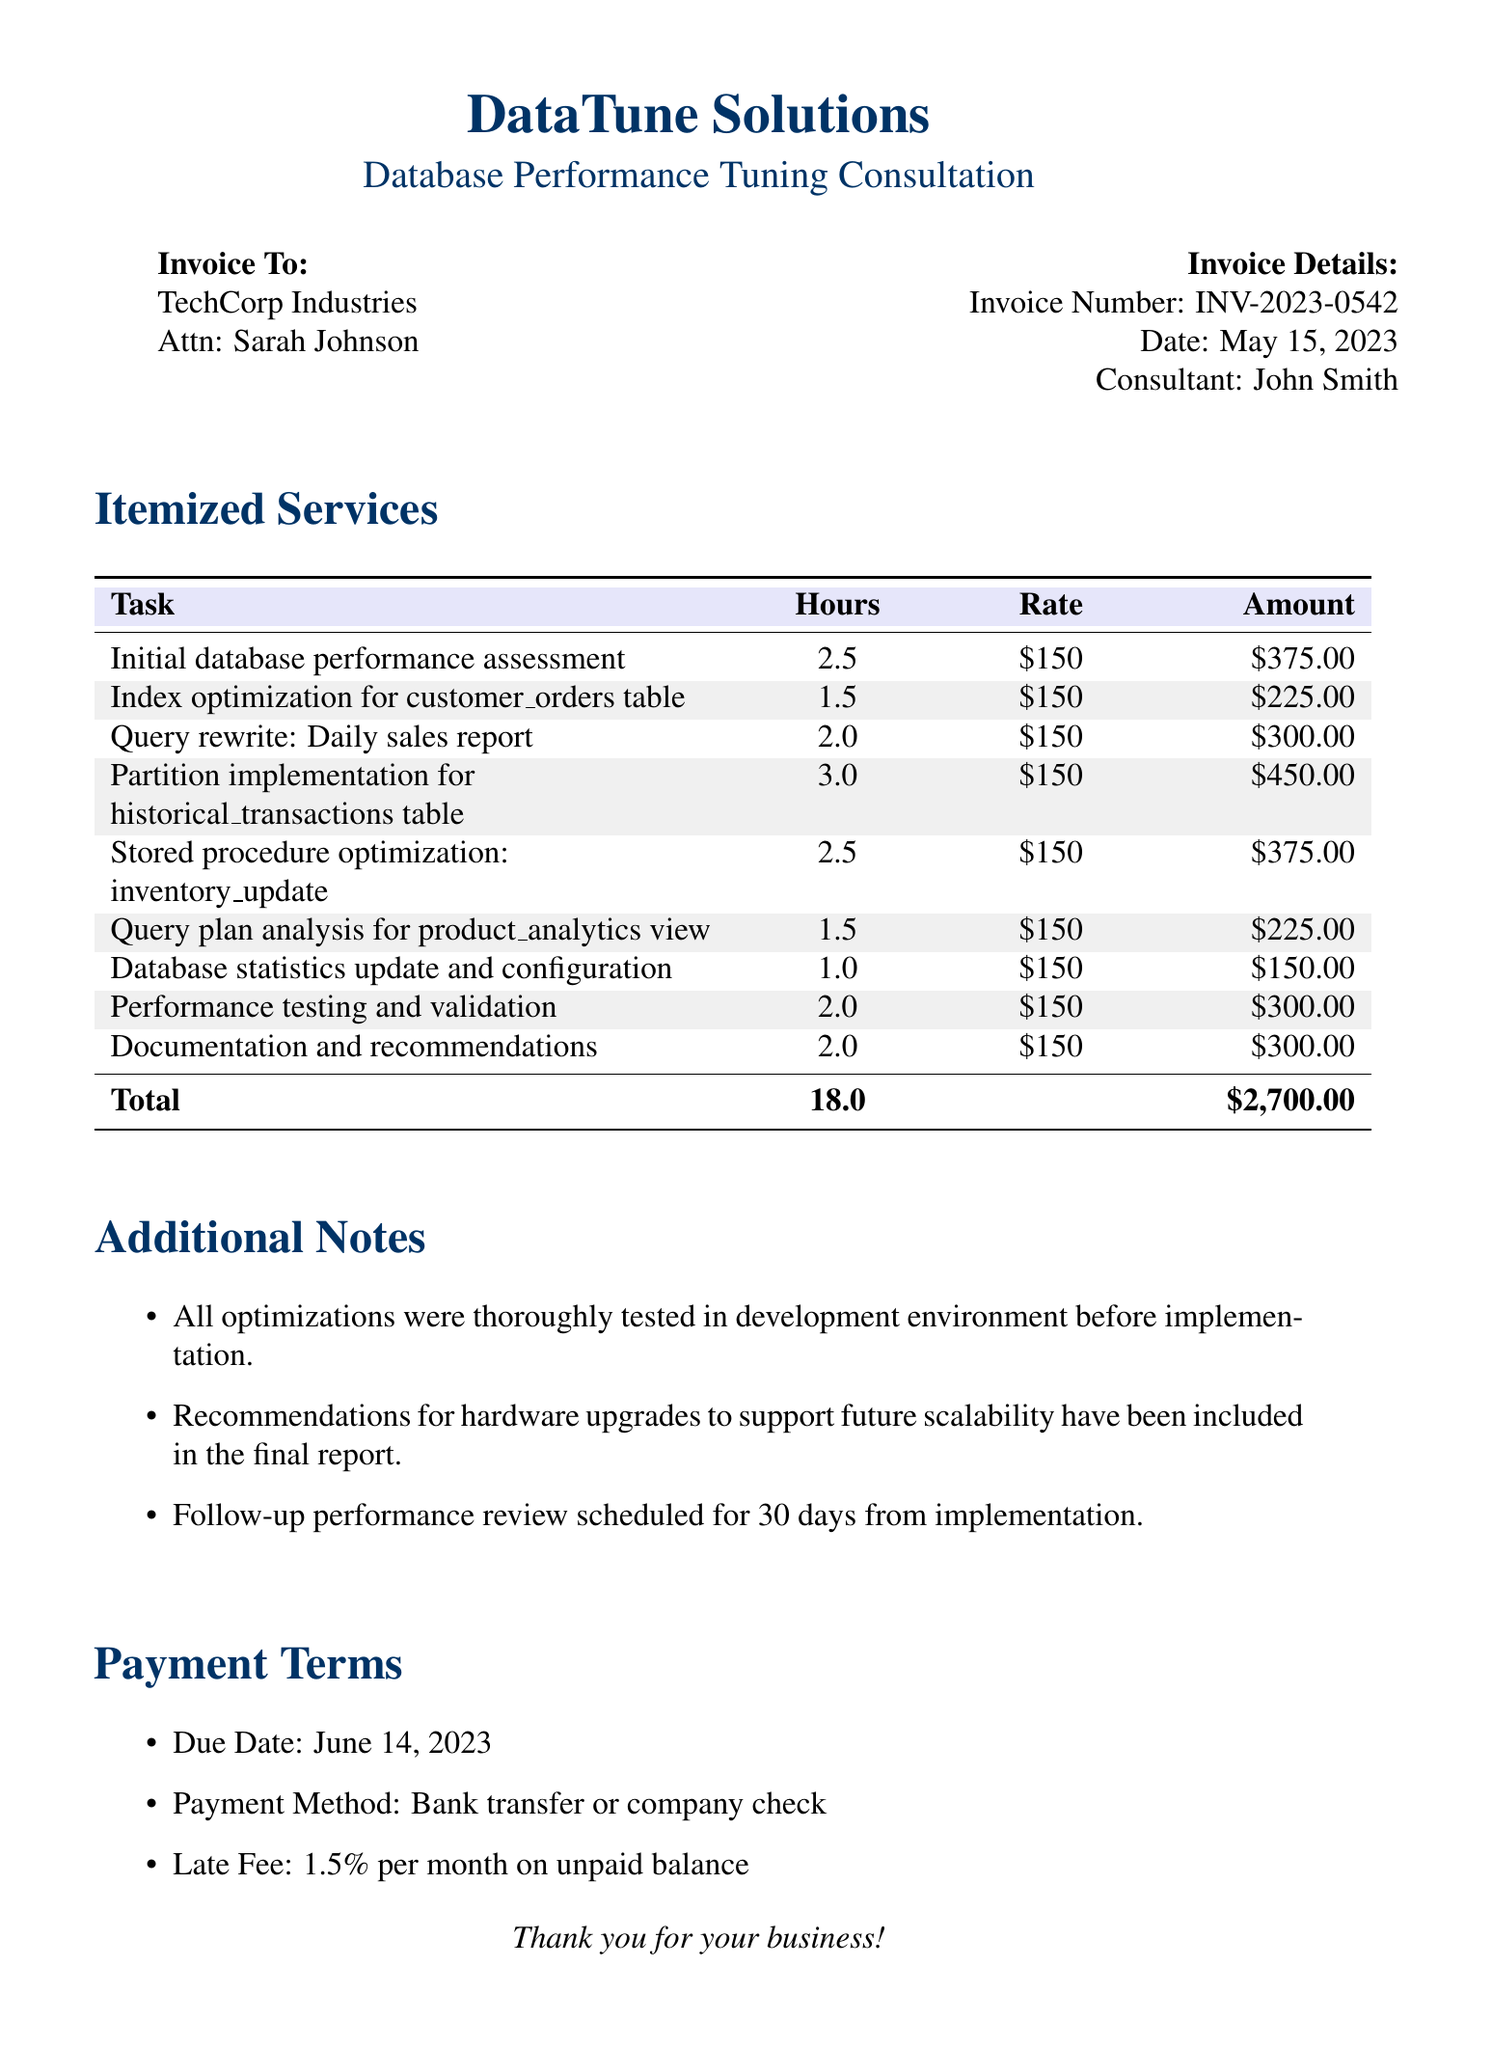what is the consultant's name? The consultant's name listed in the invoice details is John Smith.
Answer: John Smith what is the total time spent on optimization tasks? The total time spent is the sum of time spent on all listed tasks, which is 2.5 + 1.5 + 2 + 3 + 2.5 + 1.5 + 1 + 2 + 2 = 18.
Answer: 18.0 what task took the longest to complete? The task that took the longest to complete is "Partition implementation for historical_transactions table," which took 3 hours.
Answer: Partition implementation for historical_transactions table what is the invoice number? The invoice number is listed in the invoice details section.
Answer: INV-2023-0542 what was the hourly rate charged for the optimization tasks? The hourly rate for each of the tasks is clearly stated in the document as $150 per hour.
Answer: $150 how much is the payment due date? The document specifies that the payment due date is June 14, 2023.
Answer: June 14, 2023 what optimizations were tested before implementation? The document notes that all optimizations were thoroughly tested in the development environment before implementation.
Answer: Thoroughly tested in development environment how many line items are included in the invoice? The invoice lists a total of 9 line items for the optimization tasks performed.
Answer: 9 what is the late fee percentage on unpaid balance? The late fee percentage is explicitly mentioned under payment terms in the document.
Answer: 1.5% 